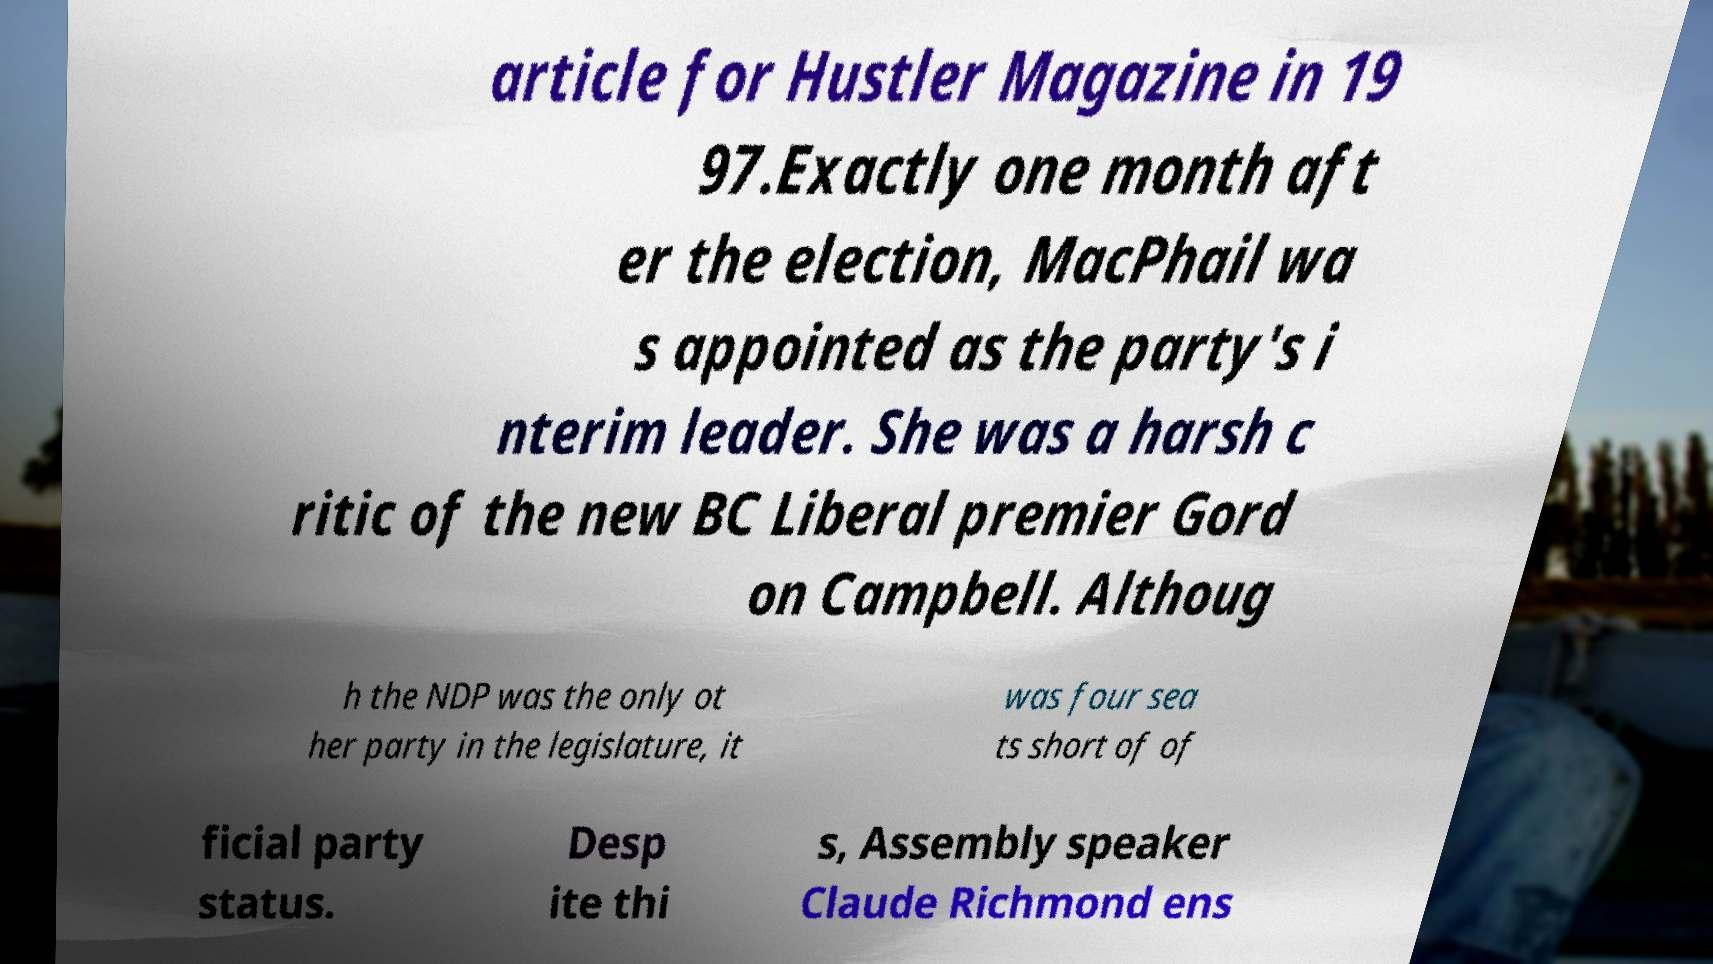I need the written content from this picture converted into text. Can you do that? article for Hustler Magazine in 19 97.Exactly one month aft er the election, MacPhail wa s appointed as the party's i nterim leader. She was a harsh c ritic of the new BC Liberal premier Gord on Campbell. Althoug h the NDP was the only ot her party in the legislature, it was four sea ts short of of ficial party status. Desp ite thi s, Assembly speaker Claude Richmond ens 